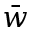<formula> <loc_0><loc_0><loc_500><loc_500>\bar { w }</formula> 